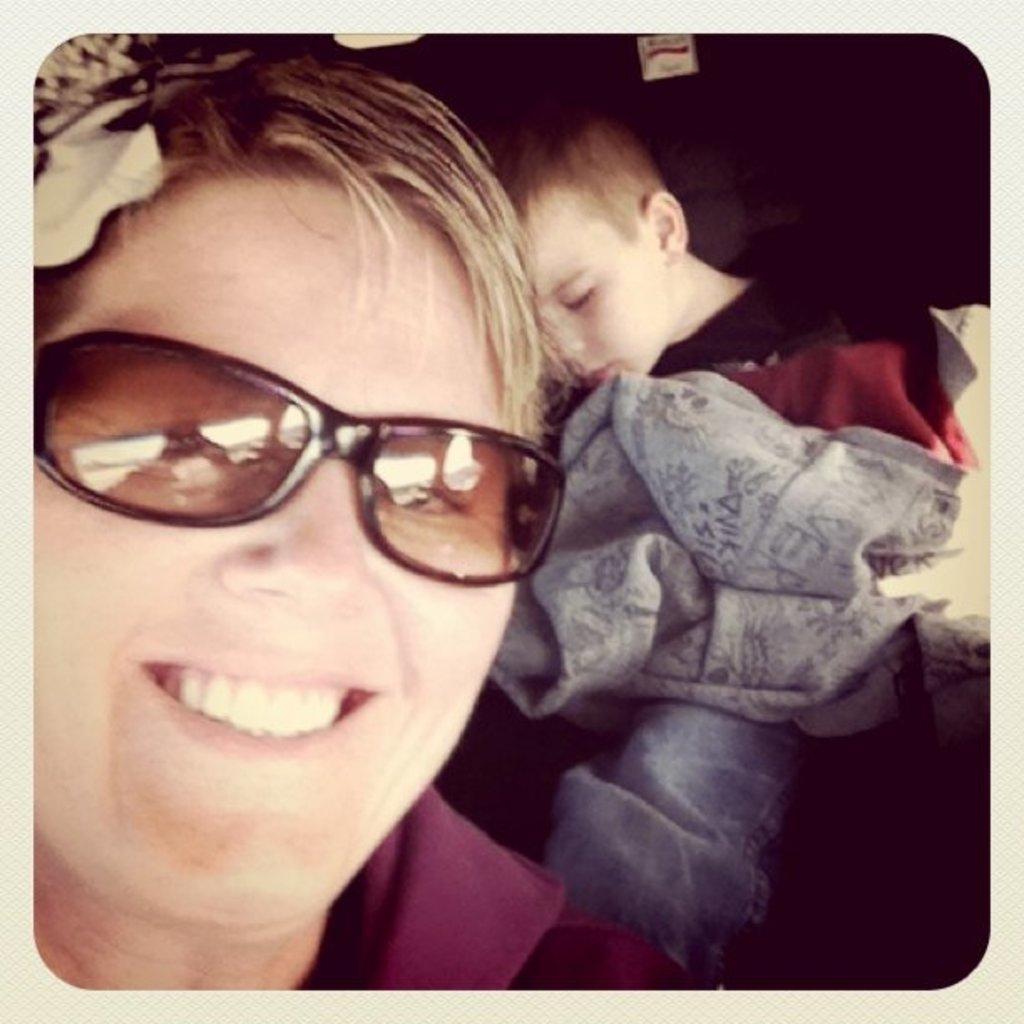Could you give a brief overview of what you see in this image? This is a photo and here we can see a person wearing glasses and there is a kid and we can see a cloth. 